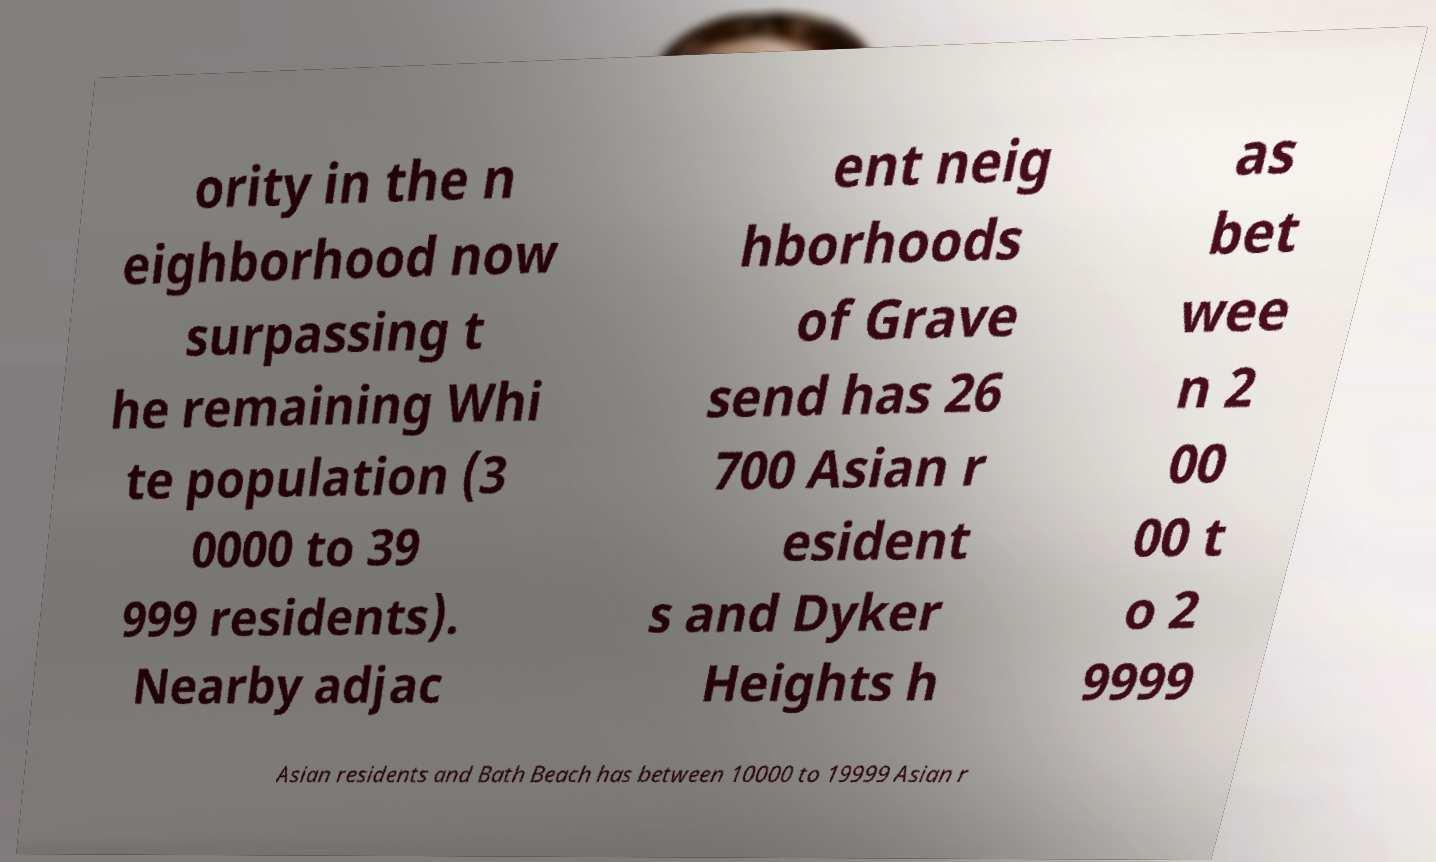Could you extract and type out the text from this image? ority in the n eighborhood now surpassing t he remaining Whi te population (3 0000 to 39 999 residents). Nearby adjac ent neig hborhoods of Grave send has 26 700 Asian r esident s and Dyker Heights h as bet wee n 2 00 00 t o 2 9999 Asian residents and Bath Beach has between 10000 to 19999 Asian r 